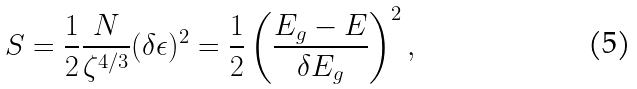Convert formula to latex. <formula><loc_0><loc_0><loc_500><loc_500>S = \frac { 1 } { 2 } \frac { N } { \zeta ^ { 4 / 3 } } ( \delta \epsilon ) ^ { 2 } = \frac { 1 } { 2 } \left ( \frac { E _ { g } - E } { \delta E _ { g } } \right ) ^ { 2 } ,</formula> 